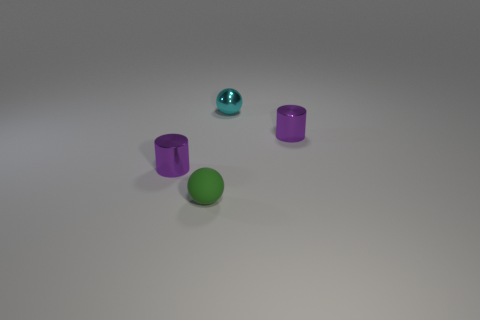Add 3 rubber balls. How many objects exist? 7 Subtract 0 yellow blocks. How many objects are left? 4 Subtract all small metal things. Subtract all matte objects. How many objects are left? 0 Add 4 tiny cyan shiny objects. How many tiny cyan shiny objects are left? 5 Add 3 metallic cylinders. How many metallic cylinders exist? 5 